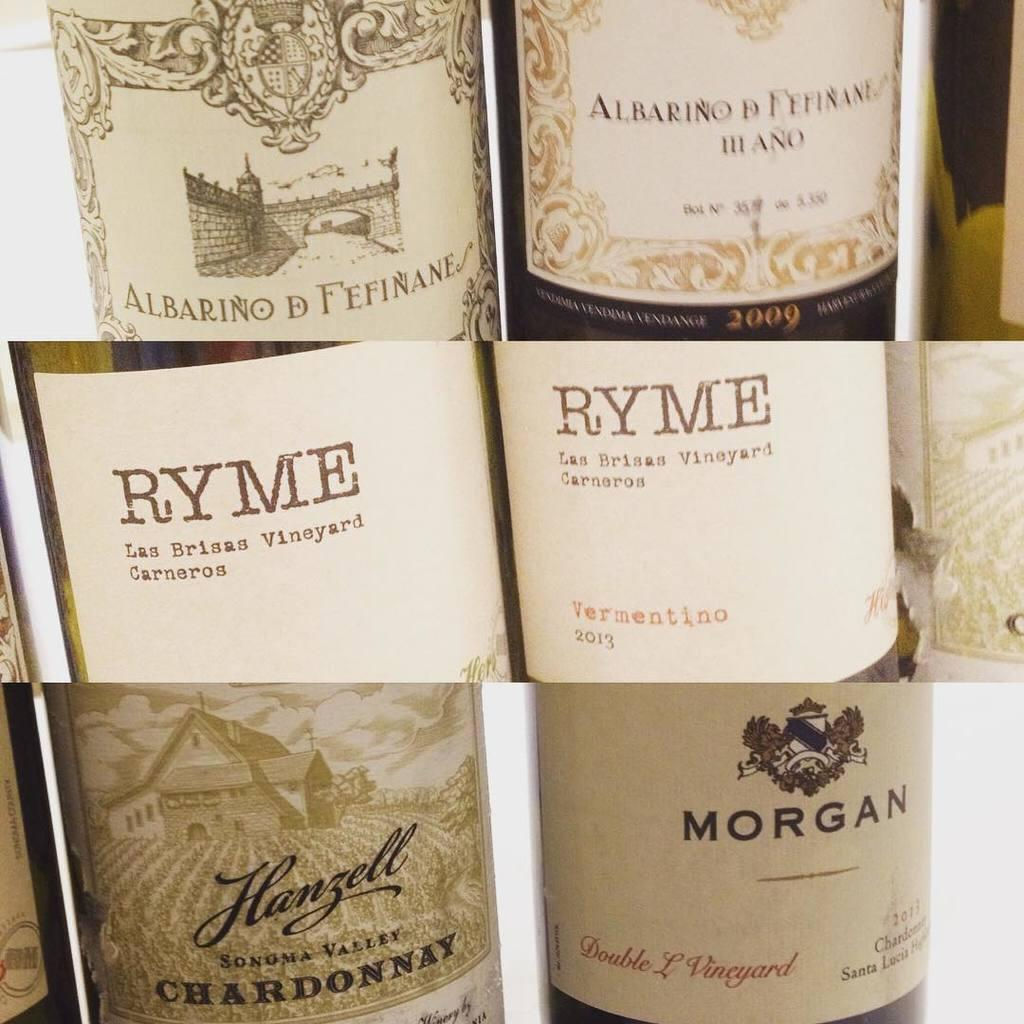<image>
Give a short and clear explanation of the subsequent image. Bottles of chardonnay and other liquor are labeled Ryme. 